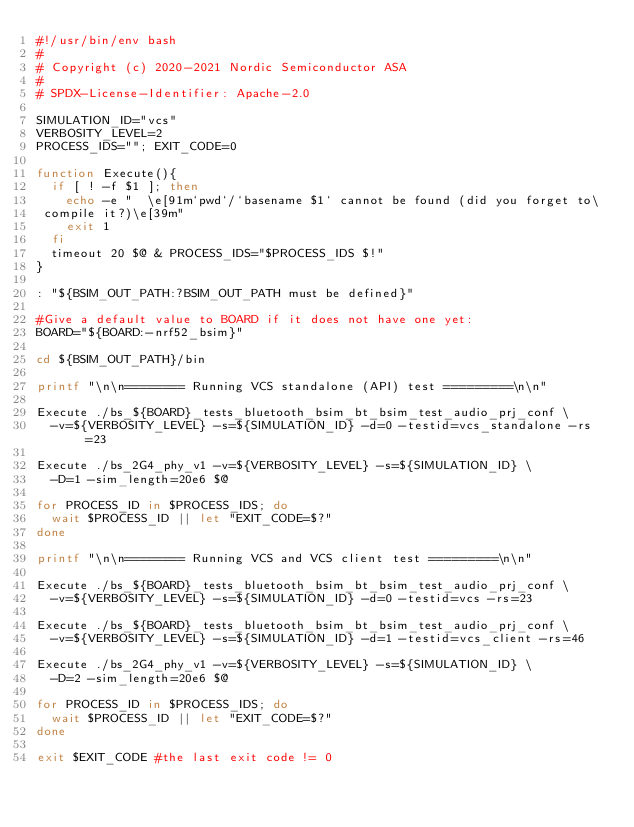Convert code to text. <code><loc_0><loc_0><loc_500><loc_500><_Bash_>#!/usr/bin/env bash
#
# Copyright (c) 2020-2021 Nordic Semiconductor ASA
#
# SPDX-License-Identifier: Apache-2.0

SIMULATION_ID="vcs"
VERBOSITY_LEVEL=2
PROCESS_IDS=""; EXIT_CODE=0

function Execute(){
  if [ ! -f $1 ]; then
    echo -e "  \e[91m`pwd`/`basename $1` cannot be found (did you forget to\
 compile it?)\e[39m"
    exit 1
  fi
  timeout 20 $@ & PROCESS_IDS="$PROCESS_IDS $!"
}

: "${BSIM_OUT_PATH:?BSIM_OUT_PATH must be defined}"

#Give a default value to BOARD if it does not have one yet:
BOARD="${BOARD:-nrf52_bsim}"

cd ${BSIM_OUT_PATH}/bin

printf "\n\n======== Running VCS standalone (API) test =========\n\n"

Execute ./bs_${BOARD}_tests_bluetooth_bsim_bt_bsim_test_audio_prj_conf \
  -v=${VERBOSITY_LEVEL} -s=${SIMULATION_ID} -d=0 -testid=vcs_standalone -rs=23

Execute ./bs_2G4_phy_v1 -v=${VERBOSITY_LEVEL} -s=${SIMULATION_ID} \
  -D=1 -sim_length=20e6 $@

for PROCESS_ID in $PROCESS_IDS; do
  wait $PROCESS_ID || let "EXIT_CODE=$?"
done

printf "\n\n======== Running VCS and VCS client test =========\n\n"

Execute ./bs_${BOARD}_tests_bluetooth_bsim_bt_bsim_test_audio_prj_conf \
  -v=${VERBOSITY_LEVEL} -s=${SIMULATION_ID} -d=0 -testid=vcs -rs=23

Execute ./bs_${BOARD}_tests_bluetooth_bsim_bt_bsim_test_audio_prj_conf \
  -v=${VERBOSITY_LEVEL} -s=${SIMULATION_ID} -d=1 -testid=vcs_client -rs=46

Execute ./bs_2G4_phy_v1 -v=${VERBOSITY_LEVEL} -s=${SIMULATION_ID} \
  -D=2 -sim_length=20e6 $@

for PROCESS_ID in $PROCESS_IDS; do
  wait $PROCESS_ID || let "EXIT_CODE=$?"
done

exit $EXIT_CODE #the last exit code != 0
</code> 